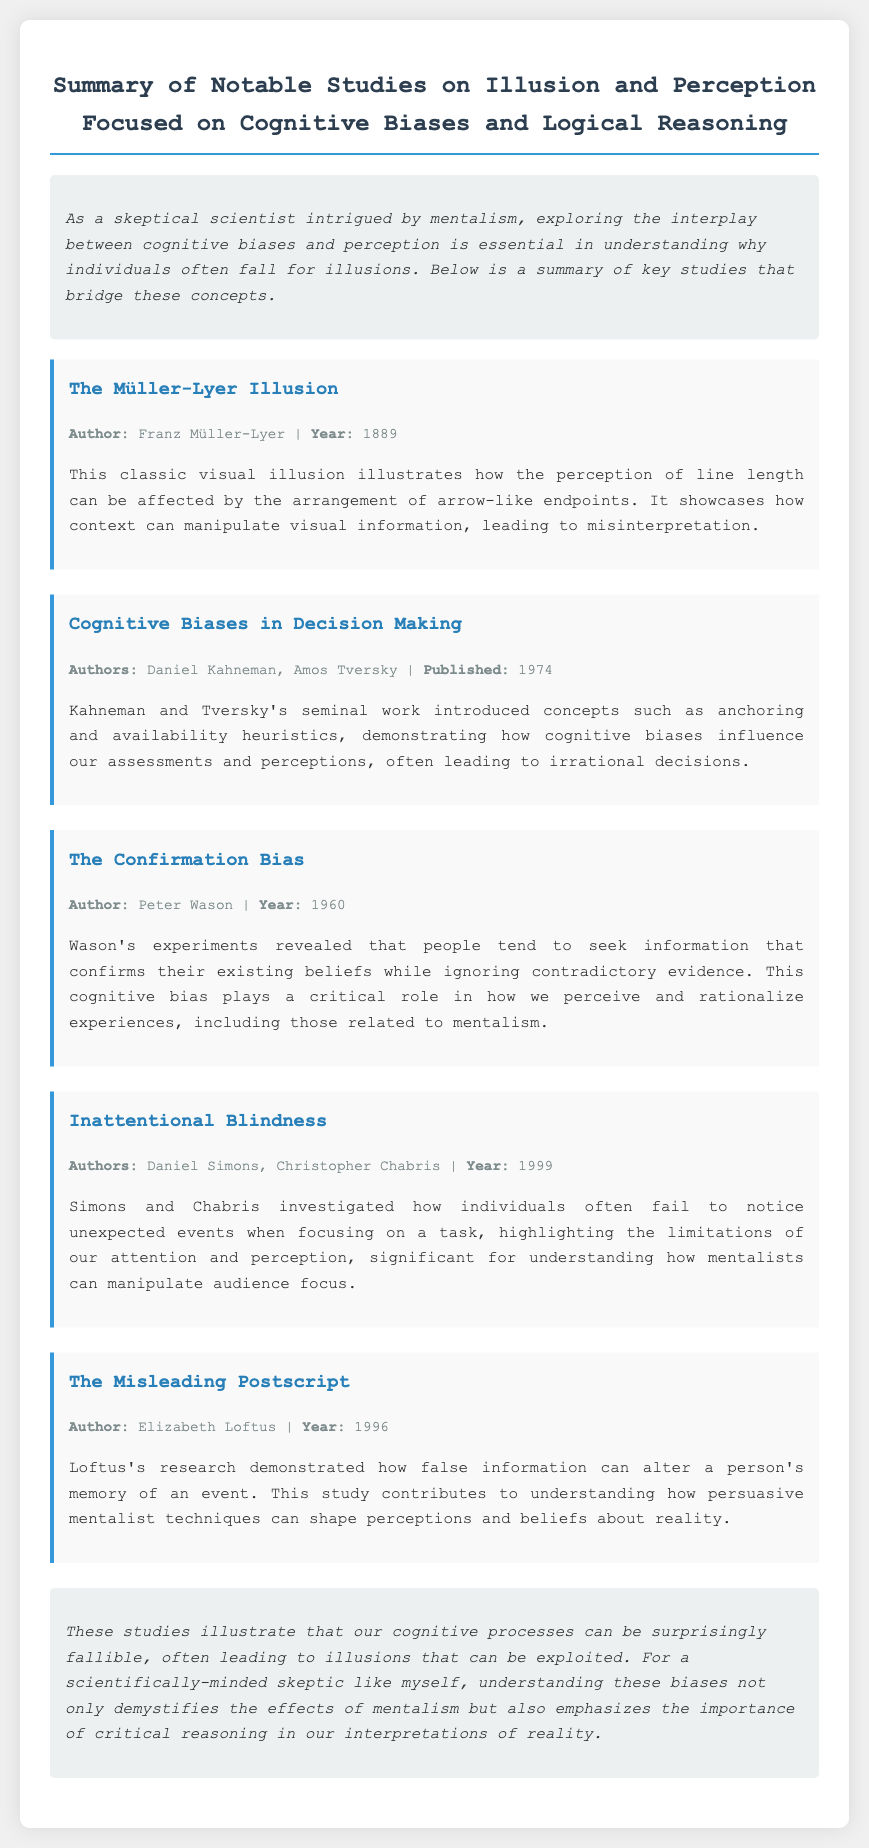What is the main topic of the document? The title indicates that the document summarizes studies on illusion and perception focused on cognitive biases and logical reasoning.
Answer: Illusion and perception Who authored the study on the Müller-Lyer illusion? The meta information for the study provides the author's name.
Answer: Franz Müller-Lyer In what year was the study on cognitive biases in decision making published? The meta information for the study includes the publication year.
Answer: 1974 What is the primary focus of the study by Simons and Chabris? The summary outlines that their study focuses on inattentional blindness and how people miss unexpected events.
Answer: Inattentional blindness Which author conducted research on the Confirmation Bias? The study meta lists the author's name for that research.
Answer: Peter Wason What cognitive bias indicates the tendency to seek confirming information? The summary explicitly defines the concept related to the study.
Answer: Confirmation Bias How are cognitive processes described in the conclusion? The conclusion summarizes the findings related to cognitive processes and their reliability.
Answer: Surprisingly fallible What persuasive technique is discussed in relation to shaping perceptions? The study by Loftus highlights how false information affects memory, which aligns with persuasive techniques.
Answer: Misleading Postscript What visual phenomenon is illustrated by the Müller-Lyer illusion? The summary of this study describes the nature of the visual illusion involved.
Answer: Line length perception 